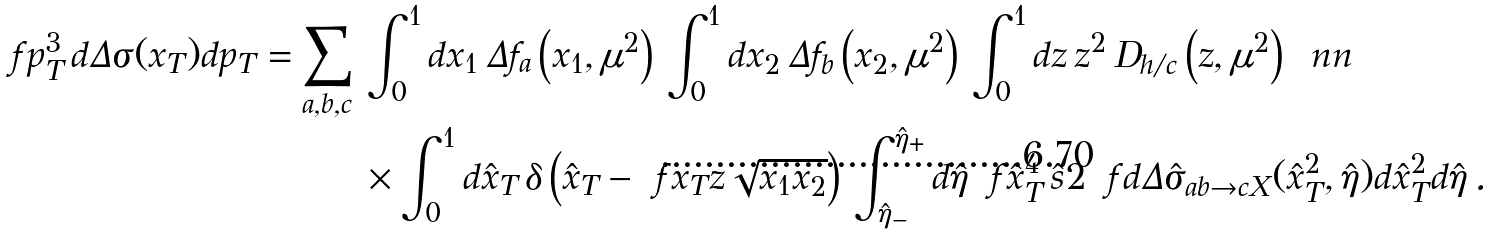<formula> <loc_0><loc_0><loc_500><loc_500>\ f { p _ { T } ^ { 3 } \, d \Delta \sigma ( x _ { T } ) } { d p _ { T } } = \sum _ { a , b , c } \, & \int _ { 0 } ^ { 1 } d x _ { 1 } \, \Delta f _ { a } \left ( x _ { 1 } , \mu ^ { 2 } \right ) \, \int _ { 0 } ^ { 1 } d x _ { 2 } \, \Delta f _ { b } \left ( x _ { 2 } , \mu ^ { 2 } \right ) \, \int _ { 0 } ^ { 1 } d z \, z ^ { 2 } \, D _ { h / c } \left ( z , \mu ^ { 2 } \right ) \, \ n n \\ & \times \int _ { 0 } ^ { 1 } d \hat { x } _ { T } \, \delta \left ( \hat { x } _ { T } - \ f { x _ { T } } { z \sqrt { x _ { 1 } x _ { 2 } } } \right ) \, \int _ { \hat { \eta } _ { - } } ^ { \hat { \eta } _ { + } } d \hat { \eta } \, \ f { \hat { x } _ { T } ^ { 4 } \, \hat { s } } { 2 } \, \ f { d \Delta \hat { \sigma } _ { a b \rightarrow c X } ( \hat { x } _ { T } ^ { 2 } , \hat { \eta } ) } { d \hat { x } _ { T } ^ { 2 } d \hat { \eta } } \, .</formula> 